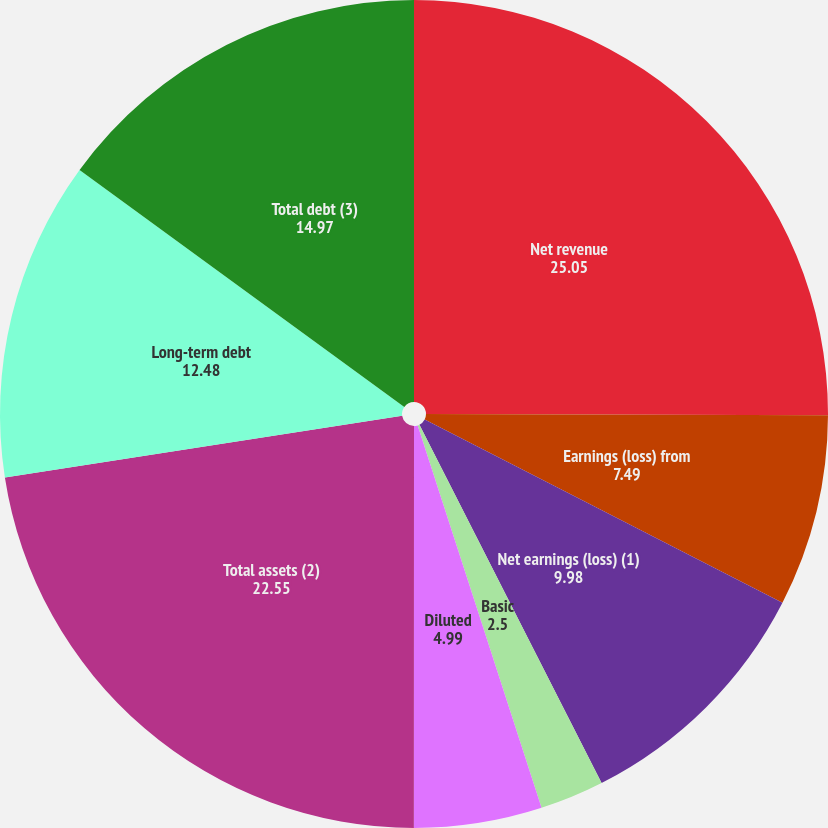Convert chart to OTSL. <chart><loc_0><loc_0><loc_500><loc_500><pie_chart><fcel>Net revenue<fcel>Earnings (loss) from<fcel>Net earnings (loss) (1)<fcel>Basic<fcel>Diluted<fcel>Cash dividends declared per<fcel>Total assets (2)<fcel>Long-term debt<fcel>Total debt (3)<nl><fcel>25.05%<fcel>7.49%<fcel>9.98%<fcel>2.5%<fcel>4.99%<fcel>0.0%<fcel>22.55%<fcel>12.48%<fcel>14.97%<nl></chart> 